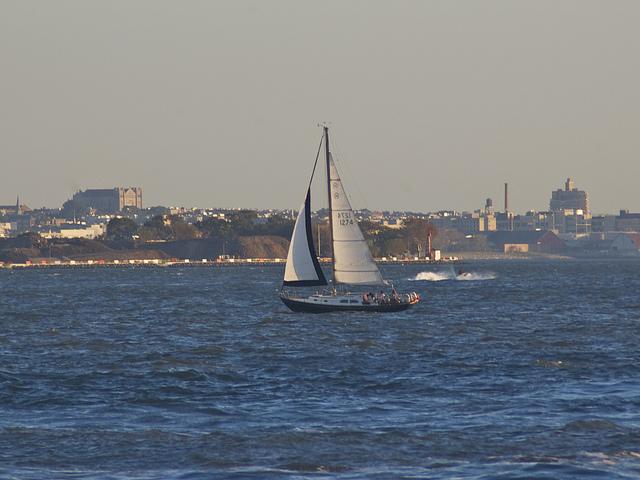Is the water calm?
Quick response, please. Yes. Does it look industrial?
Give a very brief answer. Yes. What ocean is this?
Give a very brief answer. Pacific. What color is the on the boat in the center of the image?
Be succinct. White. What type of boat is that?
Keep it brief. Sailboat. What city is this in?
Write a very short answer. Seattle. 